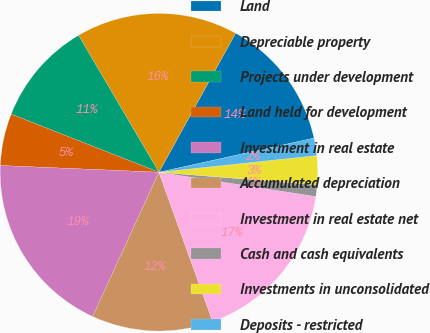Convert chart to OTSL. <chart><loc_0><loc_0><loc_500><loc_500><pie_chart><fcel>Land<fcel>Depreciable property<fcel>Projects under development<fcel>Land held for development<fcel>Investment in real estate<fcel>Accumulated depreciation<fcel>Investment in real estate net<fcel>Cash and cash equivalents<fcel>Investments in unconsolidated<fcel>Deposits - restricted<nl><fcel>13.53%<fcel>16.47%<fcel>10.59%<fcel>5.29%<fcel>18.82%<fcel>12.35%<fcel>17.06%<fcel>1.18%<fcel>2.94%<fcel>1.77%<nl></chart> 